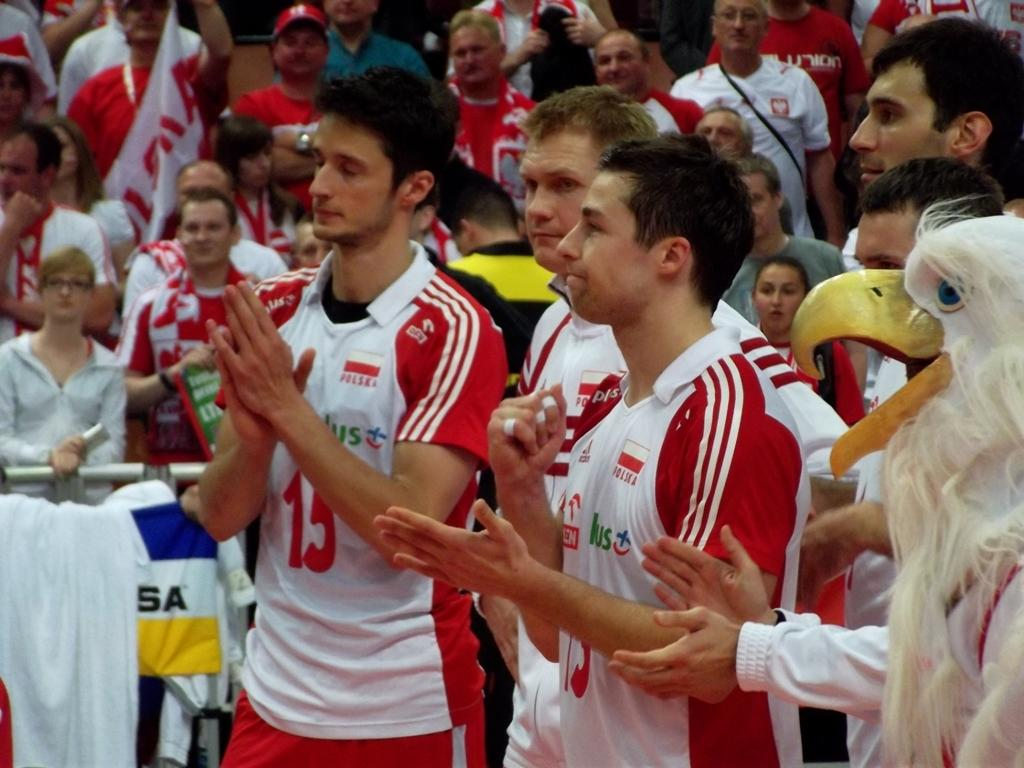<image>
Provide a brief description of the given image. A crowd of supporters with Polska below a flag on their shirts 